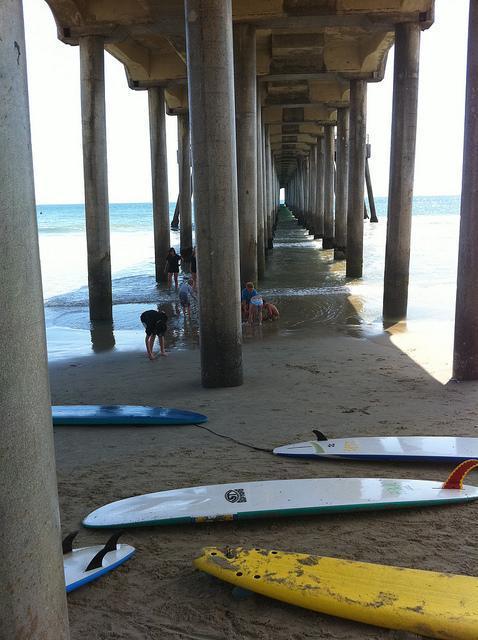How many surfboards are there?
Give a very brief answer. 5. 